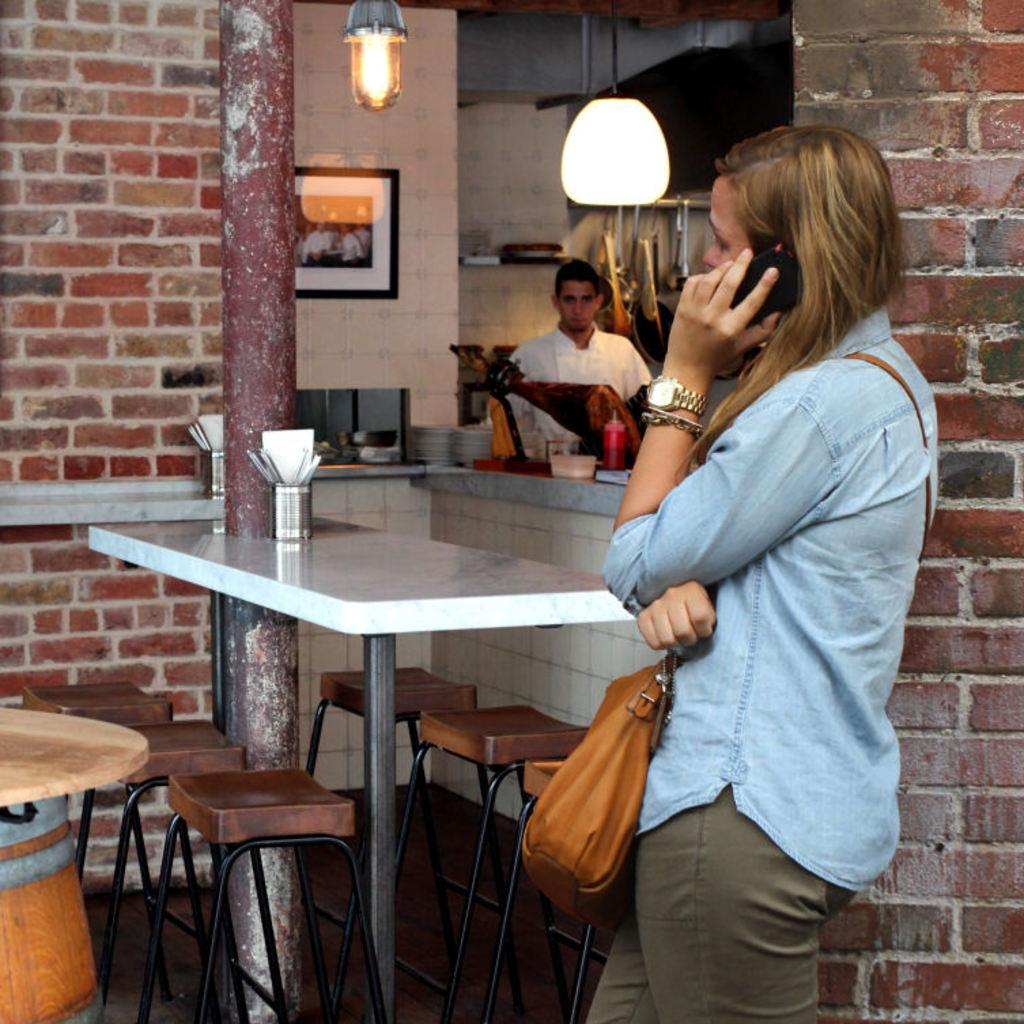What is the woman doing on the right side of the image? The woman is standing on the right side of the image and holding a phone. What can be seen in the middle of the image? There is a light and a table in the middle of the image. What furniture is present in the middle of the image? There are chairs in the middle of the image. What type of fear can be seen on the woman's face in the image? There is no indication of fear on the woman's face in the image; she is simply holding a phone. Is there a chain visible in the image? No, there is no chain present in the image. 